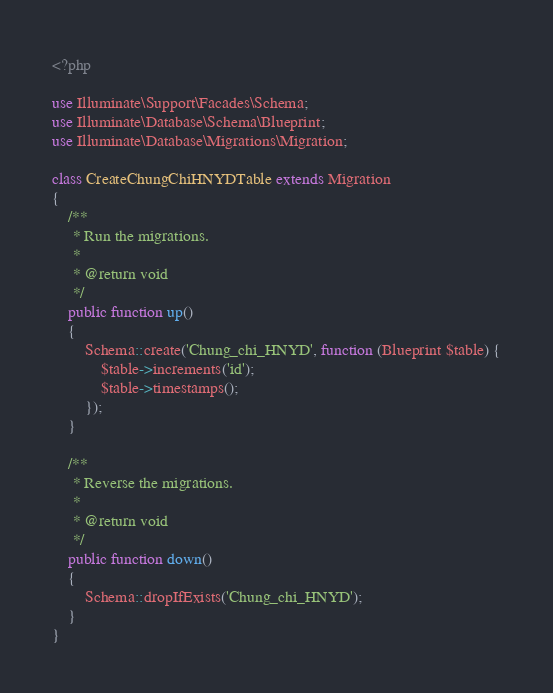Convert code to text. <code><loc_0><loc_0><loc_500><loc_500><_PHP_><?php

use Illuminate\Support\Facades\Schema;
use Illuminate\Database\Schema\Blueprint;
use Illuminate\Database\Migrations\Migration;

class CreateChungChiHNYDTable extends Migration
{
    /**
     * Run the migrations.
     *
     * @return void
     */
    public function up()
    {
        Schema::create('Chung_chi_HNYD', function (Blueprint $table) {
            $table->increments('id');
            $table->timestamps();
        });
    }

    /**
     * Reverse the migrations.
     *
     * @return void
     */
    public function down()
    {
        Schema::dropIfExists('Chung_chi_HNYD');
    }
}
</code> 